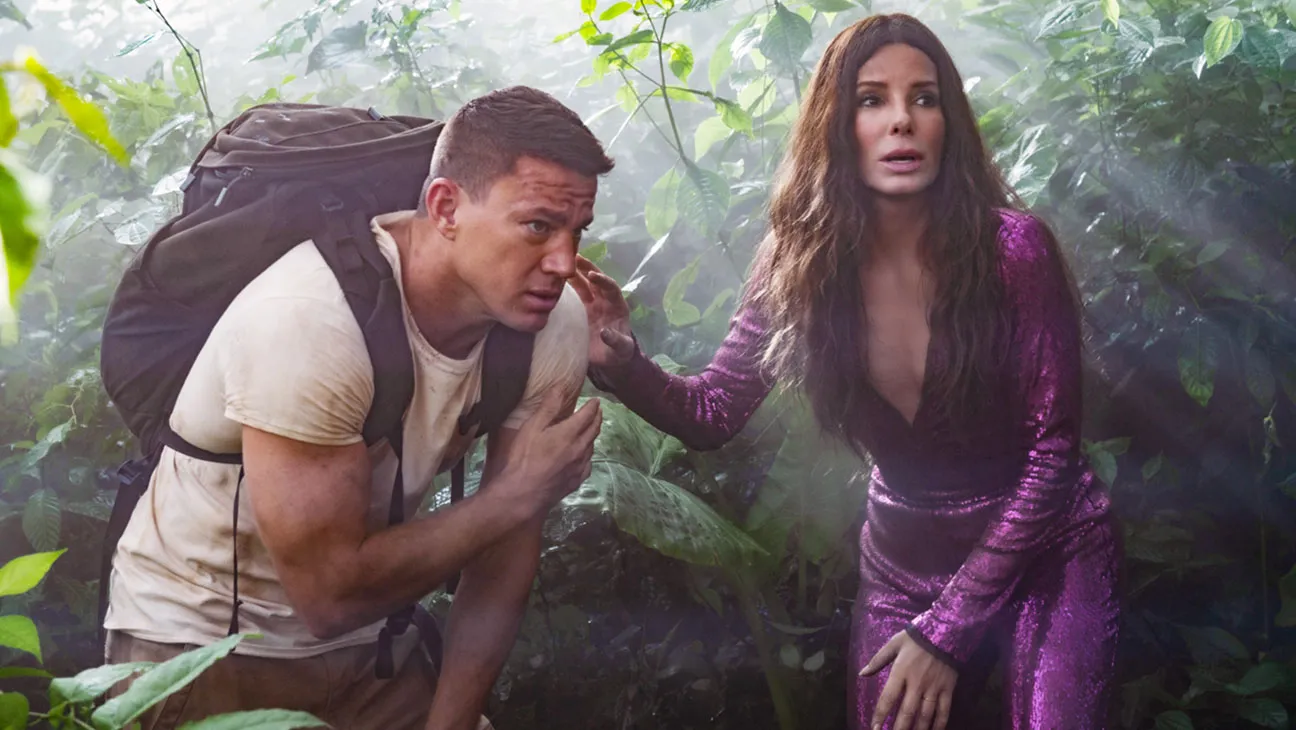What is this photo about? This image features actors dressed as characters from the movie 'The Lost City.' Sandra Bullock is on the right, wearing a vibrant, shimmering purple dress, with a concerned expression on her face. To the left, Channing Tatum is wearing a beige shirt and carrying a large backpack, also showing concern. They are surrounded by dense, lush green foliage, suggesting they are in a jungle-like environment. Their intense expressions and poses indicate that they could be facing some imminent danger or are deeply involved in an adventurous journey within the wild setting. 